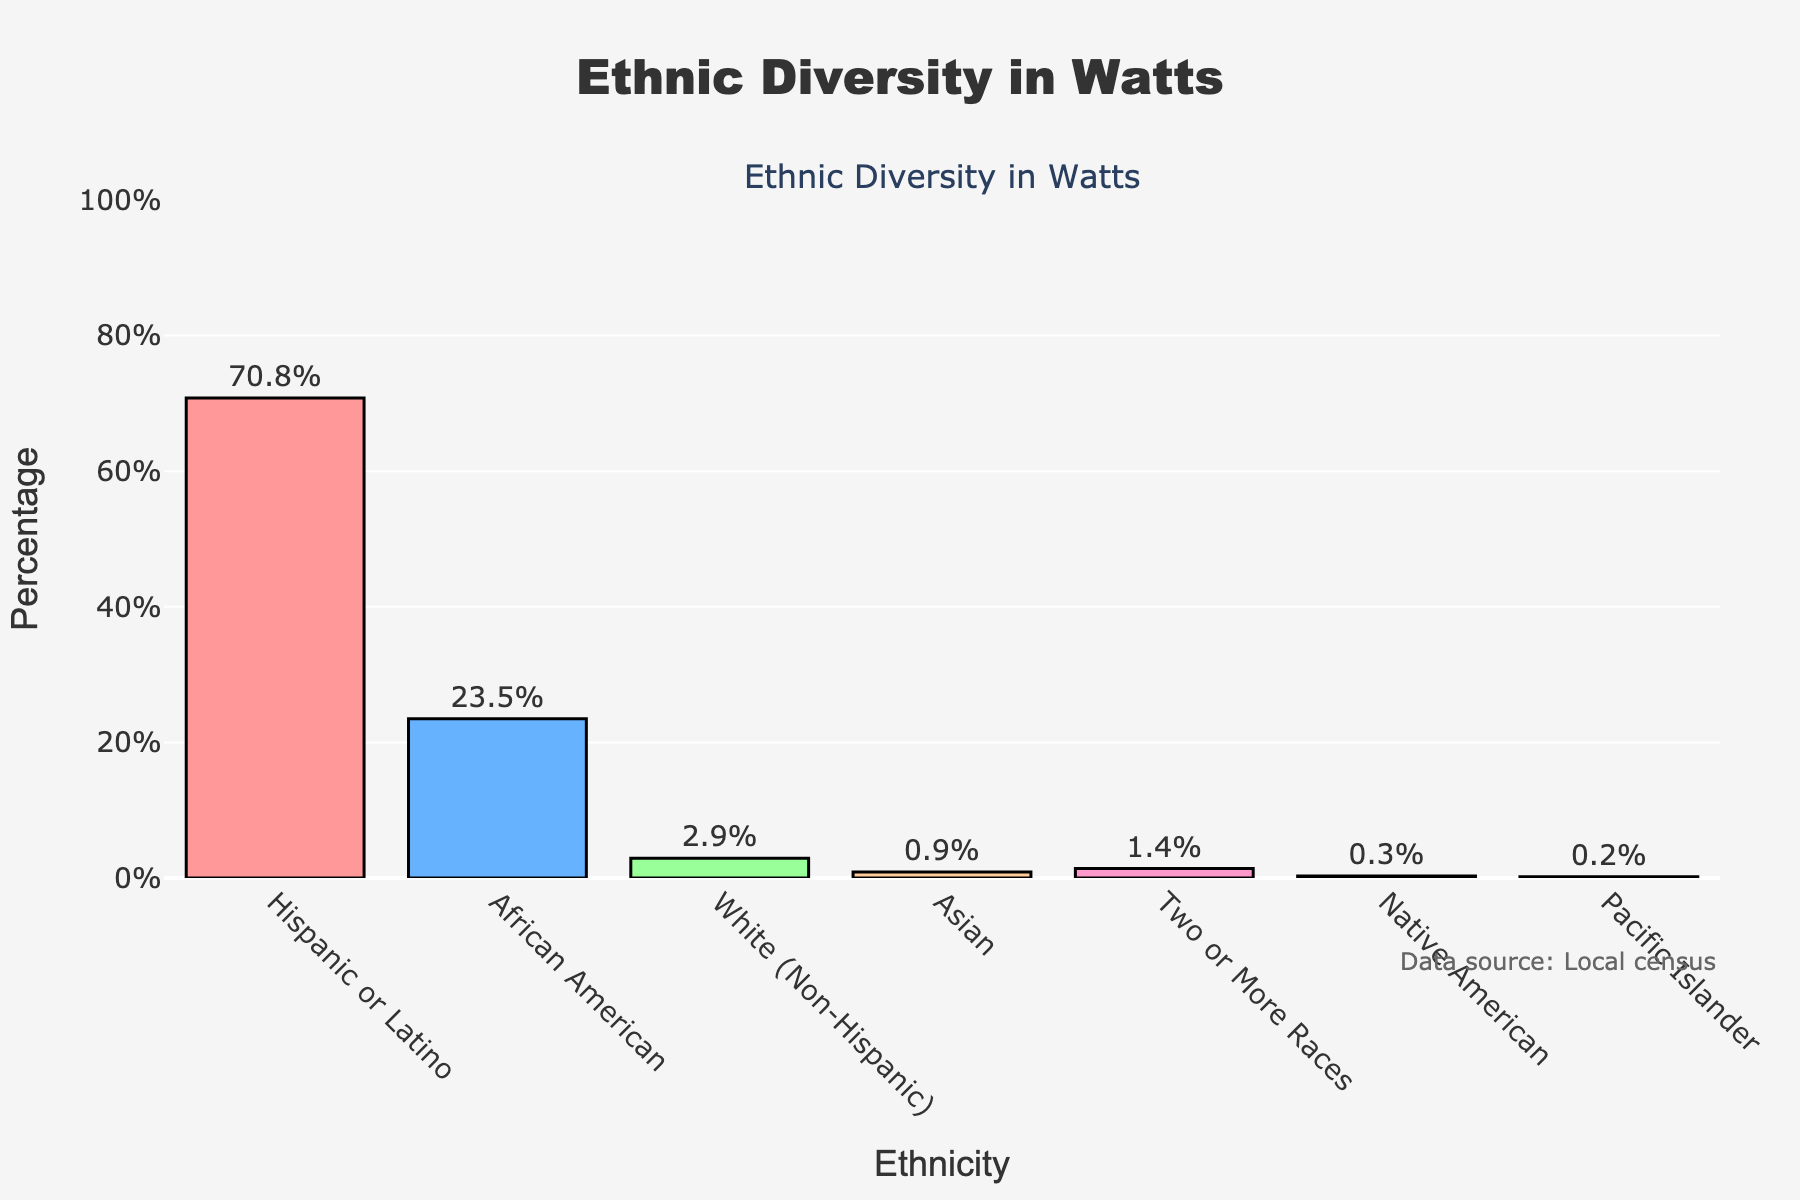What's the most represented ethnic group in Watts? Look at the bar chart and identify the tallest bar. The tallest bar represents the Hispanic or Latino group.
Answer: Hispanic or Latino What's the combined percentage of the Hispanic or Latino and African American groups? Find the percentages for Hispanic or Latino (70.8%) and African American (23.5%), and then add them together: 70.8 + 23.5 = 94.3%.
Answer: 94.3% Which ethnic group has the lowest representation in Watts? Identify the shortest bar on the chart. The shortest bar represents the Pacific Islander group, having a percentage of 0.2%.
Answer: Pacific Islander How many percentage points higher is the Hispanic or Latino group compared to the White (Non-Hispanic) group? Find the percentages for Hispanic or Latino (70.8%) and White (Non-Hispanic) (2.9%), and then calculate the difference: 70.8 - 2.9 = 67.9%.
Answer: 67.9% What is the average percentage of the least represented three ethnic groups in Watts? Identify the three least represented ethnic groups: Native American (0.3%), Pacific Islander (0.2%), and Asian (0.9%). Calculate their average by summing their percentages and dividing by 3: (0.3 + 0.2 + 0.9) / 3 = 0.467%.
Answer: 0.467% Which ethnic groups make up less than 1% of the population each? Look at the bars that are shorter and represent less than 1%. The groups are Native American (0.3%), Pacific Islander (0.2%), and Asian (0.9%).
Answer: Native American, Pacific Islander, Asian What is the total percentage of all ethnic groups shown in the chart? Sum the percentages of all ethnic groups: 70.8 + 23.5 + 2.9 + 0.9 + 1.4 + 0.3 + 0.2 = 100%.
Answer: 100% Which bar is the second tallest, and what does it represent? Identify the second tallest bar after the Hispanic or Latino bar. The second tallest bar represents the African American group with 23.5%.
Answer: African American, 23.5% How many ethnic groups have a representation of more than 1%, but less than 10%? Examine each bar and count the ones with percentages between 1% and 10%. Only the White (Non-Hispanic) and Two or More Races groups fit this criterion: 2.9% and 1.4%.
Answer: 2 (White (Non-Hispanic), Two or More Races) 